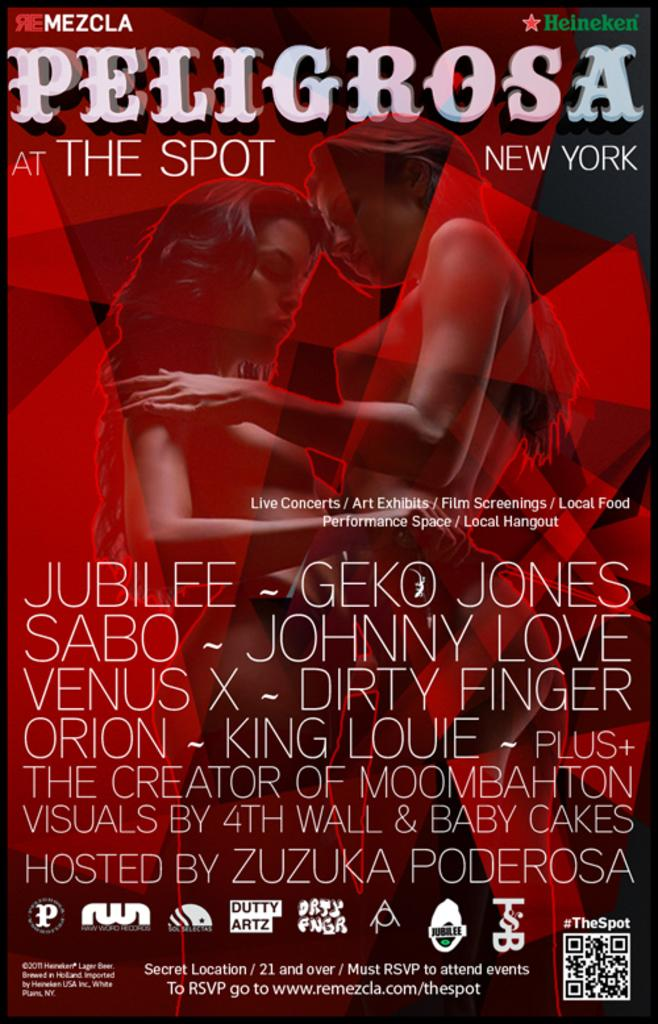<image>
Describe the image concisely. an re mezcla magazine that says 'peligrosa' on it 